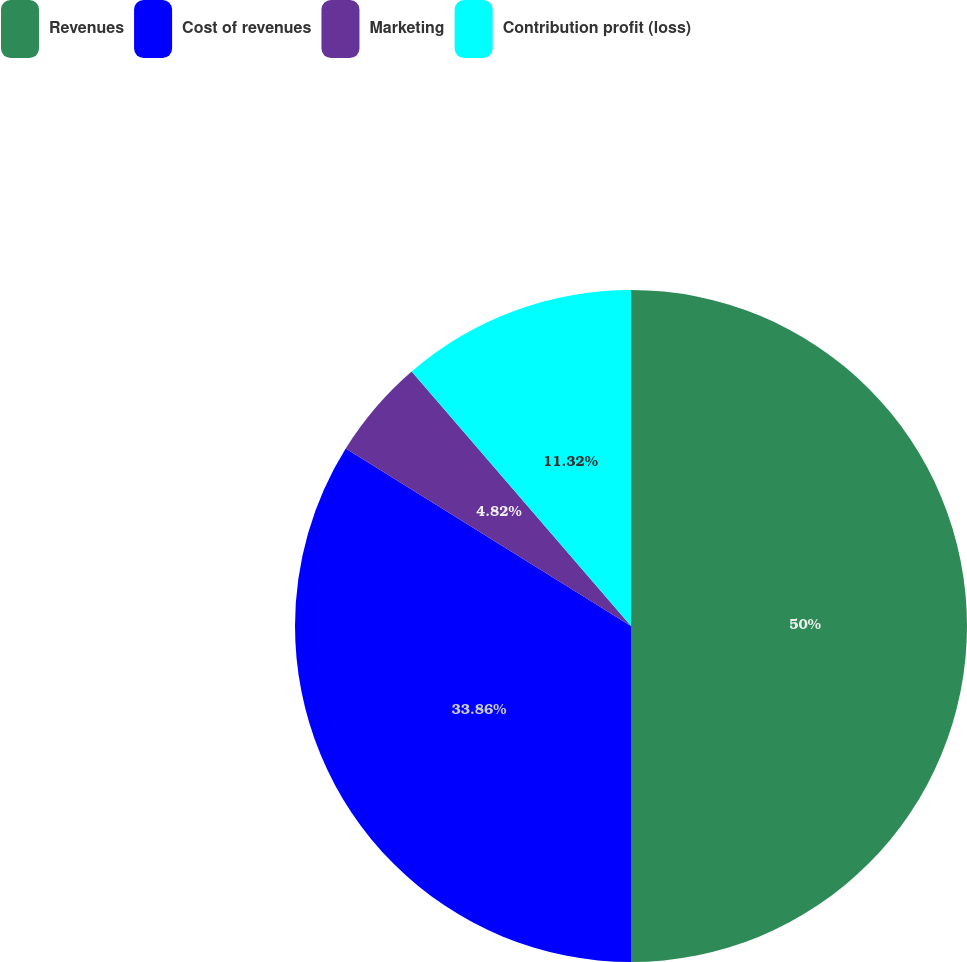Convert chart to OTSL. <chart><loc_0><loc_0><loc_500><loc_500><pie_chart><fcel>Revenues<fcel>Cost of revenues<fcel>Marketing<fcel>Contribution profit (loss)<nl><fcel>50.0%<fcel>33.86%<fcel>4.82%<fcel>11.32%<nl></chart> 